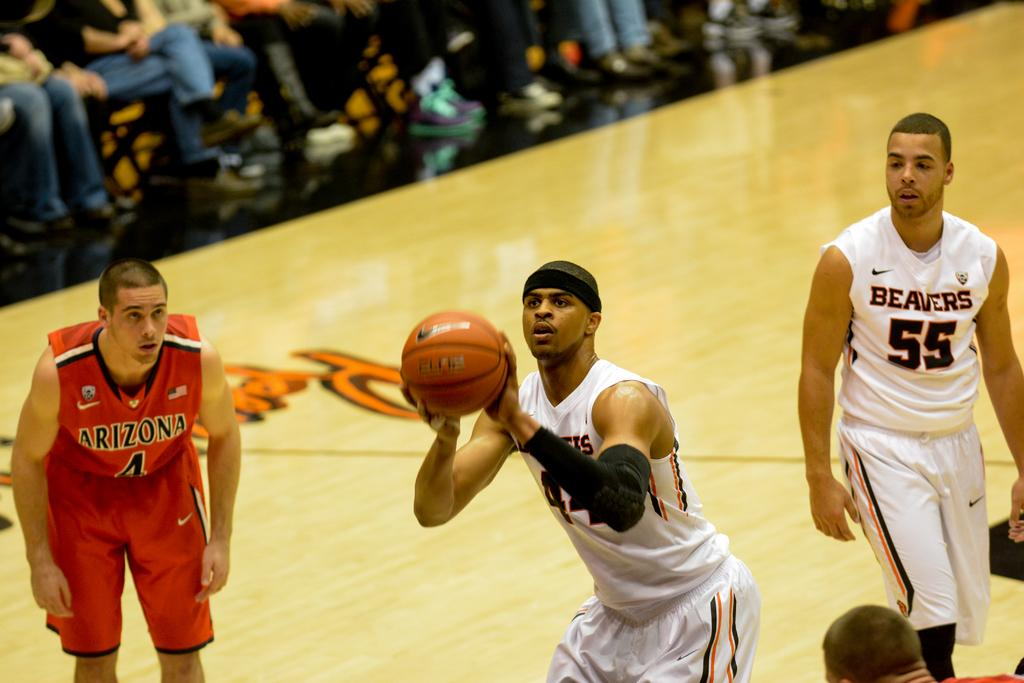Provide a one-sentence caption for the provided image. beavers player shooting free throw while arizona player #4 waits to the side and beavers player #55 stands in the back. 